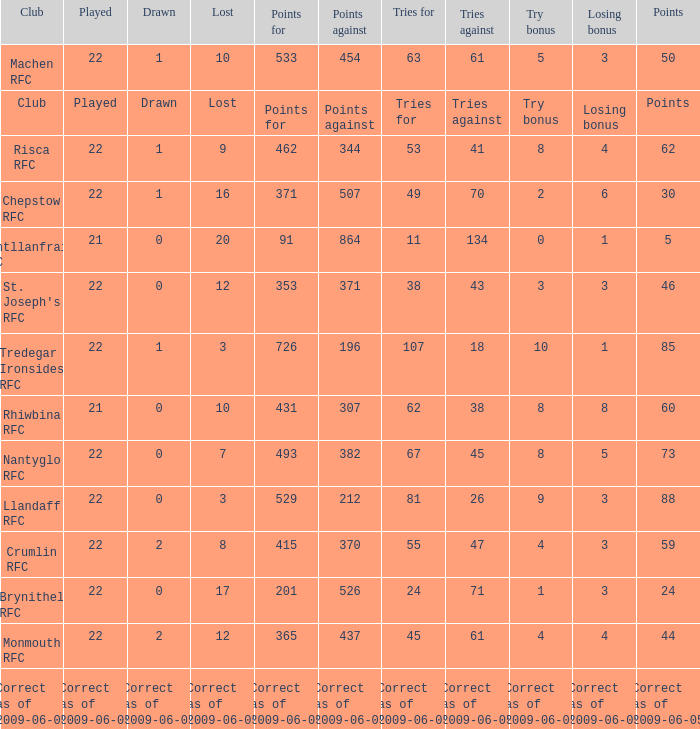If the Played was played, what is the lost? Lost. 